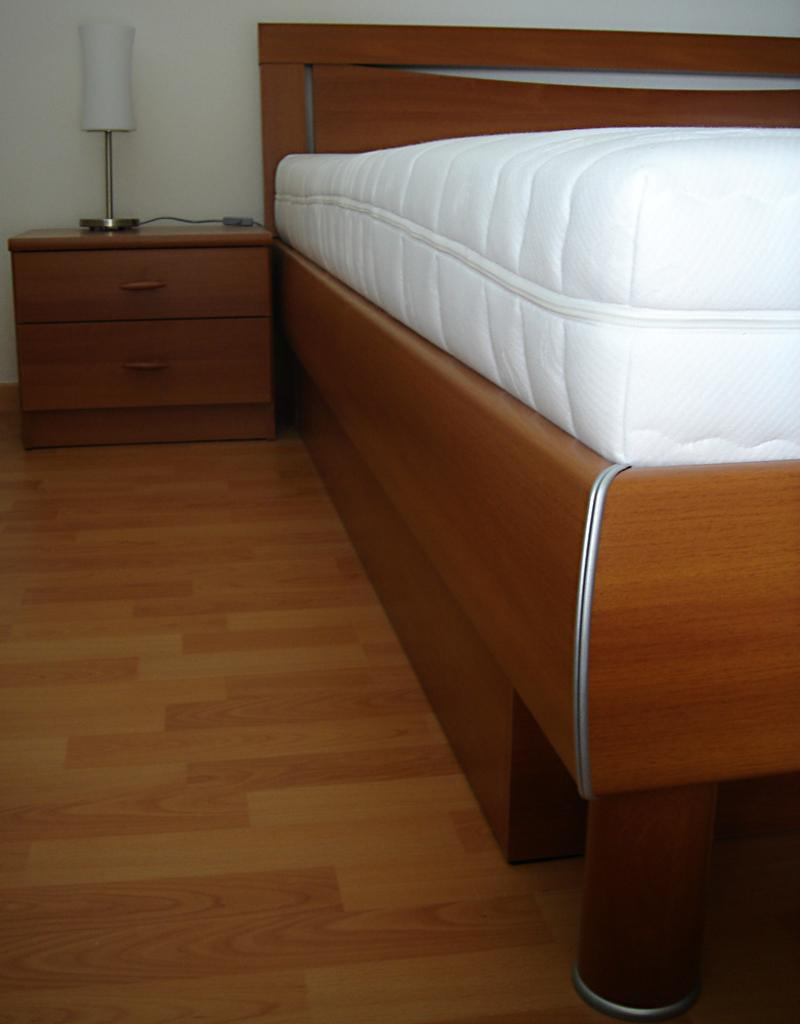What type of furniture is present in the room? There is a bed and a table with a lamp in the room. Can you describe the lighting fixture in the room? There is a lamp on the table in the room. What type of slope can be seen in the room? There is no slope present in the room; the image only shows a bed and a table with a lamp. What type of material is the grandfather clock made of in the room? There is no grandfather clock present in the room. 